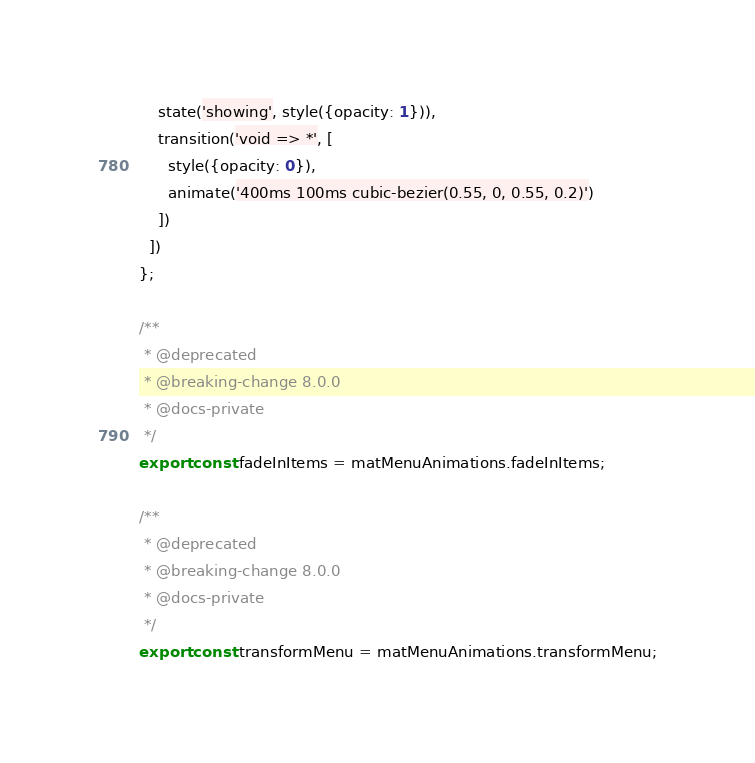<code> <loc_0><loc_0><loc_500><loc_500><_TypeScript_>    state('showing', style({opacity: 1})),
    transition('void => *', [
      style({opacity: 0}),
      animate('400ms 100ms cubic-bezier(0.55, 0, 0.55, 0.2)')
    ])
  ])
};

/**
 * @deprecated
 * @breaking-change 8.0.0
 * @docs-private
 */
export const fadeInItems = matMenuAnimations.fadeInItems;

/**
 * @deprecated
 * @breaking-change 8.0.0
 * @docs-private
 */
export const transformMenu = matMenuAnimations.transformMenu;
</code> 